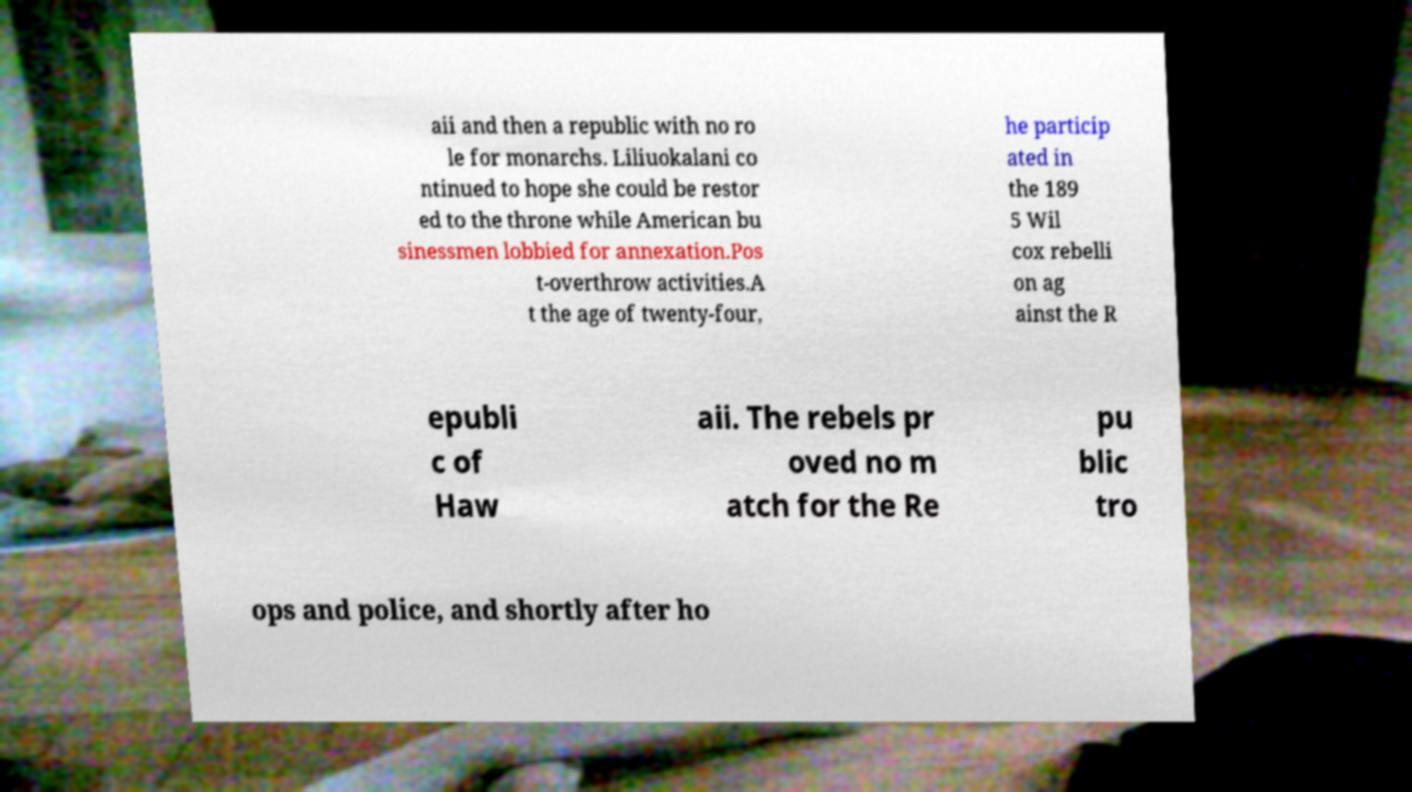Please read and relay the text visible in this image. What does it say? aii and then a republic with no ro le for monarchs. Liliuokalani co ntinued to hope she could be restor ed to the throne while American bu sinessmen lobbied for annexation.Pos t-overthrow activities.A t the age of twenty-four, he particip ated in the 189 5 Wil cox rebelli on ag ainst the R epubli c of Haw aii. The rebels pr oved no m atch for the Re pu blic tro ops and police, and shortly after ho 